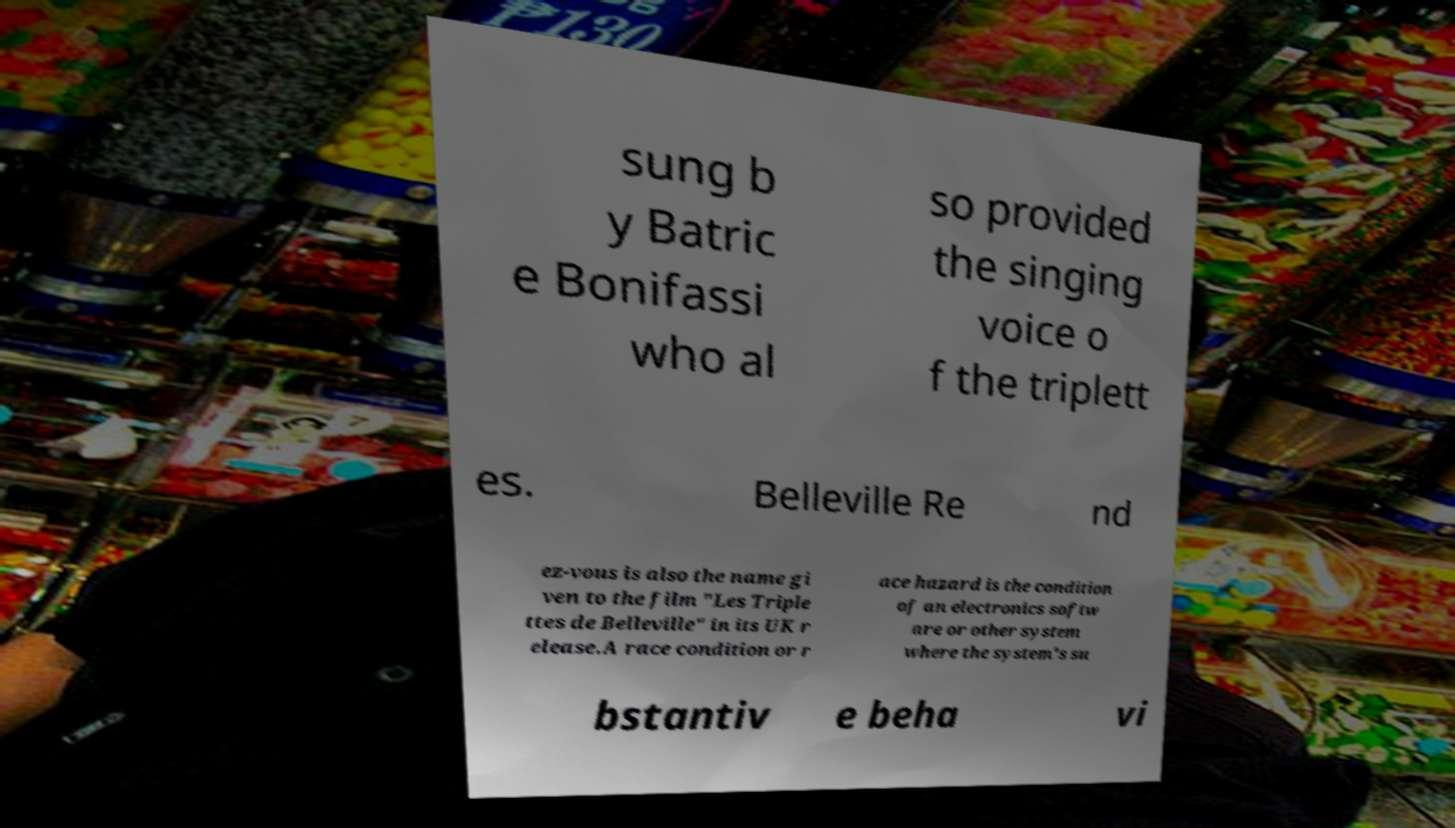Can you read and provide the text displayed in the image?This photo seems to have some interesting text. Can you extract and type it out for me? sung b y Batric e Bonifassi who al so provided the singing voice o f the triplett es. Belleville Re nd ez-vous is also the name gi ven to the film "Les Triple ttes de Belleville" in its UK r elease.A race condition or r ace hazard is the condition of an electronics softw are or other system where the system's su bstantiv e beha vi 